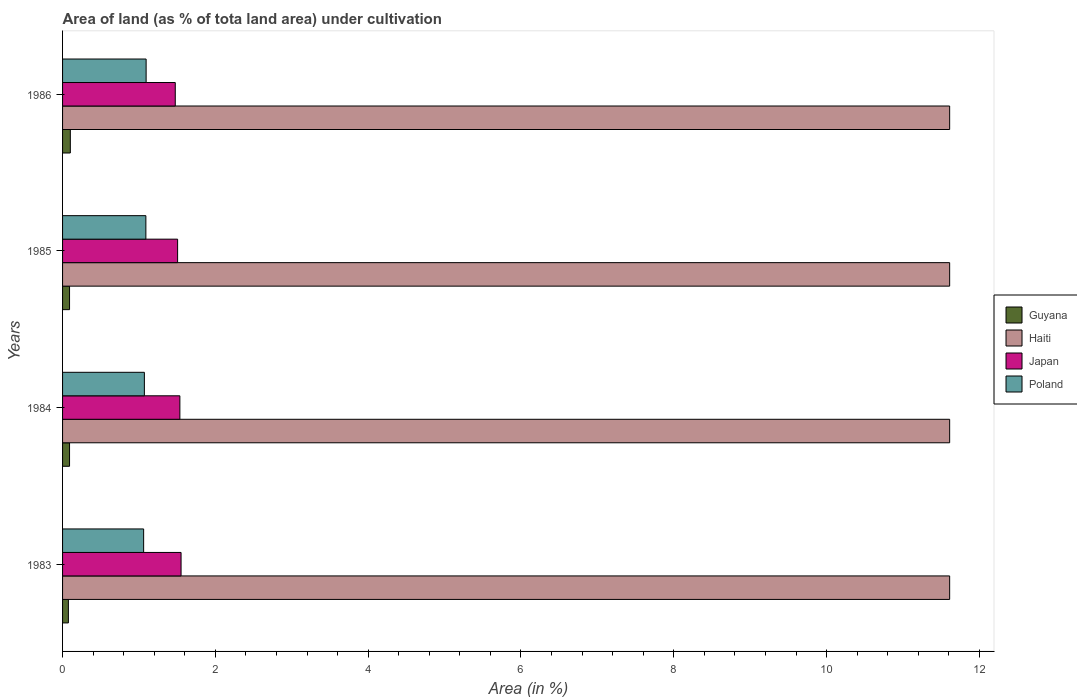How many different coloured bars are there?
Offer a very short reply. 4. How many groups of bars are there?
Give a very brief answer. 4. What is the label of the 2nd group of bars from the top?
Keep it short and to the point. 1985. What is the percentage of land under cultivation in Haiti in 1984?
Make the answer very short. 11.61. Across all years, what is the maximum percentage of land under cultivation in Haiti?
Keep it short and to the point. 11.61. Across all years, what is the minimum percentage of land under cultivation in Poland?
Give a very brief answer. 1.06. In which year was the percentage of land under cultivation in Haiti maximum?
Your answer should be compact. 1983. What is the total percentage of land under cultivation in Poland in the graph?
Provide a short and direct response. 4.32. What is the difference between the percentage of land under cultivation in Poland in 1983 and that in 1985?
Your answer should be compact. -0.03. What is the difference between the percentage of land under cultivation in Japan in 1984 and the percentage of land under cultivation in Guyana in 1986?
Your answer should be very brief. 1.43. What is the average percentage of land under cultivation in Guyana per year?
Your response must be concise. 0.09. In the year 1985, what is the difference between the percentage of land under cultivation in Poland and percentage of land under cultivation in Haiti?
Offer a terse response. -10.52. What is the ratio of the percentage of land under cultivation in Guyana in 1983 to that in 1984?
Provide a short and direct response. 0.83. Is the percentage of land under cultivation in Japan in 1983 less than that in 1985?
Your answer should be very brief. No. What is the difference between the highest and the second highest percentage of land under cultivation in Poland?
Ensure brevity in your answer.  0. What is the difference between the highest and the lowest percentage of land under cultivation in Poland?
Your answer should be compact. 0.03. Is it the case that in every year, the sum of the percentage of land under cultivation in Haiti and percentage of land under cultivation in Japan is greater than the sum of percentage of land under cultivation in Poland and percentage of land under cultivation in Guyana?
Provide a short and direct response. No. What does the 3rd bar from the bottom in 1985 represents?
Provide a succinct answer. Japan. Is it the case that in every year, the sum of the percentage of land under cultivation in Haiti and percentage of land under cultivation in Guyana is greater than the percentage of land under cultivation in Poland?
Offer a terse response. Yes. How many bars are there?
Give a very brief answer. 16. Are all the bars in the graph horizontal?
Give a very brief answer. Yes. Are the values on the major ticks of X-axis written in scientific E-notation?
Keep it short and to the point. No. Does the graph contain any zero values?
Your answer should be very brief. No. Where does the legend appear in the graph?
Keep it short and to the point. Center right. How many legend labels are there?
Provide a succinct answer. 4. What is the title of the graph?
Provide a succinct answer. Area of land (as % of tota land area) under cultivation. What is the label or title of the X-axis?
Your answer should be compact. Area (in %). What is the Area (in %) in Guyana in 1983?
Your answer should be compact. 0.08. What is the Area (in %) of Haiti in 1983?
Your answer should be very brief. 11.61. What is the Area (in %) in Japan in 1983?
Provide a short and direct response. 1.55. What is the Area (in %) in Poland in 1983?
Offer a very short reply. 1.06. What is the Area (in %) of Guyana in 1984?
Make the answer very short. 0.09. What is the Area (in %) of Haiti in 1984?
Offer a terse response. 11.61. What is the Area (in %) in Japan in 1984?
Offer a terse response. 1.54. What is the Area (in %) of Poland in 1984?
Your answer should be very brief. 1.07. What is the Area (in %) of Guyana in 1985?
Offer a terse response. 0.09. What is the Area (in %) in Haiti in 1985?
Provide a succinct answer. 11.61. What is the Area (in %) in Japan in 1985?
Ensure brevity in your answer.  1.51. What is the Area (in %) of Poland in 1985?
Your answer should be very brief. 1.09. What is the Area (in %) of Guyana in 1986?
Offer a very short reply. 0.1. What is the Area (in %) of Haiti in 1986?
Your answer should be very brief. 11.61. What is the Area (in %) of Japan in 1986?
Provide a succinct answer. 1.48. What is the Area (in %) in Poland in 1986?
Your answer should be compact. 1.09. Across all years, what is the maximum Area (in %) in Guyana?
Keep it short and to the point. 0.1. Across all years, what is the maximum Area (in %) of Haiti?
Offer a terse response. 11.61. Across all years, what is the maximum Area (in %) of Japan?
Your answer should be compact. 1.55. Across all years, what is the maximum Area (in %) of Poland?
Your answer should be compact. 1.09. Across all years, what is the minimum Area (in %) in Guyana?
Provide a short and direct response. 0.08. Across all years, what is the minimum Area (in %) in Haiti?
Keep it short and to the point. 11.61. Across all years, what is the minimum Area (in %) in Japan?
Make the answer very short. 1.48. Across all years, what is the minimum Area (in %) in Poland?
Make the answer very short. 1.06. What is the total Area (in %) in Guyana in the graph?
Make the answer very short. 0.36. What is the total Area (in %) of Haiti in the graph?
Your answer should be very brief. 46.44. What is the total Area (in %) of Japan in the graph?
Offer a very short reply. 6.07. What is the total Area (in %) in Poland in the graph?
Provide a short and direct response. 4.32. What is the difference between the Area (in %) of Guyana in 1983 and that in 1984?
Your answer should be very brief. -0.02. What is the difference between the Area (in %) in Japan in 1983 and that in 1984?
Offer a very short reply. 0.02. What is the difference between the Area (in %) of Poland in 1983 and that in 1984?
Make the answer very short. -0.01. What is the difference between the Area (in %) in Guyana in 1983 and that in 1985?
Make the answer very short. -0.02. What is the difference between the Area (in %) in Haiti in 1983 and that in 1985?
Your response must be concise. 0. What is the difference between the Area (in %) in Japan in 1983 and that in 1985?
Keep it short and to the point. 0.05. What is the difference between the Area (in %) of Poland in 1983 and that in 1985?
Offer a terse response. -0.03. What is the difference between the Area (in %) in Guyana in 1983 and that in 1986?
Your response must be concise. -0.03. What is the difference between the Area (in %) of Japan in 1983 and that in 1986?
Offer a terse response. 0.08. What is the difference between the Area (in %) of Poland in 1983 and that in 1986?
Make the answer very short. -0.03. What is the difference between the Area (in %) in Japan in 1984 and that in 1985?
Provide a short and direct response. 0.03. What is the difference between the Area (in %) of Poland in 1984 and that in 1985?
Your answer should be compact. -0.02. What is the difference between the Area (in %) of Guyana in 1984 and that in 1986?
Provide a succinct answer. -0.01. What is the difference between the Area (in %) in Haiti in 1984 and that in 1986?
Offer a terse response. 0. What is the difference between the Area (in %) of Japan in 1984 and that in 1986?
Provide a succinct answer. 0.06. What is the difference between the Area (in %) in Poland in 1984 and that in 1986?
Give a very brief answer. -0.02. What is the difference between the Area (in %) of Guyana in 1985 and that in 1986?
Your answer should be very brief. -0.01. What is the difference between the Area (in %) in Japan in 1985 and that in 1986?
Your answer should be compact. 0.03. What is the difference between the Area (in %) of Poland in 1985 and that in 1986?
Your answer should be compact. -0. What is the difference between the Area (in %) in Guyana in 1983 and the Area (in %) in Haiti in 1984?
Ensure brevity in your answer.  -11.53. What is the difference between the Area (in %) in Guyana in 1983 and the Area (in %) in Japan in 1984?
Provide a short and direct response. -1.46. What is the difference between the Area (in %) in Guyana in 1983 and the Area (in %) in Poland in 1984?
Make the answer very short. -0.99. What is the difference between the Area (in %) in Haiti in 1983 and the Area (in %) in Japan in 1984?
Provide a succinct answer. 10.08. What is the difference between the Area (in %) of Haiti in 1983 and the Area (in %) of Poland in 1984?
Keep it short and to the point. 10.54. What is the difference between the Area (in %) of Japan in 1983 and the Area (in %) of Poland in 1984?
Your response must be concise. 0.48. What is the difference between the Area (in %) of Guyana in 1983 and the Area (in %) of Haiti in 1985?
Offer a very short reply. -11.53. What is the difference between the Area (in %) in Guyana in 1983 and the Area (in %) in Japan in 1985?
Your answer should be very brief. -1.43. What is the difference between the Area (in %) of Guyana in 1983 and the Area (in %) of Poland in 1985?
Make the answer very short. -1.01. What is the difference between the Area (in %) of Haiti in 1983 and the Area (in %) of Japan in 1985?
Offer a very short reply. 10.11. What is the difference between the Area (in %) of Haiti in 1983 and the Area (in %) of Poland in 1985?
Your answer should be compact. 10.52. What is the difference between the Area (in %) in Japan in 1983 and the Area (in %) in Poland in 1985?
Ensure brevity in your answer.  0.46. What is the difference between the Area (in %) in Guyana in 1983 and the Area (in %) in Haiti in 1986?
Make the answer very short. -11.53. What is the difference between the Area (in %) of Guyana in 1983 and the Area (in %) of Japan in 1986?
Give a very brief answer. -1.4. What is the difference between the Area (in %) of Guyana in 1983 and the Area (in %) of Poland in 1986?
Give a very brief answer. -1.02. What is the difference between the Area (in %) in Haiti in 1983 and the Area (in %) in Japan in 1986?
Offer a terse response. 10.14. What is the difference between the Area (in %) in Haiti in 1983 and the Area (in %) in Poland in 1986?
Ensure brevity in your answer.  10.52. What is the difference between the Area (in %) of Japan in 1983 and the Area (in %) of Poland in 1986?
Your answer should be very brief. 0.46. What is the difference between the Area (in %) in Guyana in 1984 and the Area (in %) in Haiti in 1985?
Your response must be concise. -11.52. What is the difference between the Area (in %) of Guyana in 1984 and the Area (in %) of Japan in 1985?
Your response must be concise. -1.41. What is the difference between the Area (in %) in Guyana in 1984 and the Area (in %) in Poland in 1985?
Give a very brief answer. -1. What is the difference between the Area (in %) of Haiti in 1984 and the Area (in %) of Japan in 1985?
Ensure brevity in your answer.  10.11. What is the difference between the Area (in %) in Haiti in 1984 and the Area (in %) in Poland in 1985?
Provide a short and direct response. 10.52. What is the difference between the Area (in %) of Japan in 1984 and the Area (in %) of Poland in 1985?
Your answer should be compact. 0.45. What is the difference between the Area (in %) of Guyana in 1984 and the Area (in %) of Haiti in 1986?
Ensure brevity in your answer.  -11.52. What is the difference between the Area (in %) of Guyana in 1984 and the Area (in %) of Japan in 1986?
Ensure brevity in your answer.  -1.38. What is the difference between the Area (in %) of Guyana in 1984 and the Area (in %) of Poland in 1986?
Your answer should be very brief. -1. What is the difference between the Area (in %) in Haiti in 1984 and the Area (in %) in Japan in 1986?
Your response must be concise. 10.14. What is the difference between the Area (in %) in Haiti in 1984 and the Area (in %) in Poland in 1986?
Keep it short and to the point. 10.52. What is the difference between the Area (in %) in Japan in 1984 and the Area (in %) in Poland in 1986?
Make the answer very short. 0.44. What is the difference between the Area (in %) of Guyana in 1985 and the Area (in %) of Haiti in 1986?
Your answer should be very brief. -11.52. What is the difference between the Area (in %) in Guyana in 1985 and the Area (in %) in Japan in 1986?
Provide a short and direct response. -1.38. What is the difference between the Area (in %) of Guyana in 1985 and the Area (in %) of Poland in 1986?
Give a very brief answer. -1. What is the difference between the Area (in %) of Haiti in 1985 and the Area (in %) of Japan in 1986?
Make the answer very short. 10.14. What is the difference between the Area (in %) in Haiti in 1985 and the Area (in %) in Poland in 1986?
Your response must be concise. 10.52. What is the difference between the Area (in %) in Japan in 1985 and the Area (in %) in Poland in 1986?
Offer a terse response. 0.41. What is the average Area (in %) of Guyana per year?
Keep it short and to the point. 0.09. What is the average Area (in %) in Haiti per year?
Ensure brevity in your answer.  11.61. What is the average Area (in %) of Japan per year?
Make the answer very short. 1.52. What is the average Area (in %) of Poland per year?
Your answer should be very brief. 1.08. In the year 1983, what is the difference between the Area (in %) of Guyana and Area (in %) of Haiti?
Offer a terse response. -11.53. In the year 1983, what is the difference between the Area (in %) in Guyana and Area (in %) in Japan?
Provide a short and direct response. -1.47. In the year 1983, what is the difference between the Area (in %) of Guyana and Area (in %) of Poland?
Ensure brevity in your answer.  -0.98. In the year 1983, what is the difference between the Area (in %) in Haiti and Area (in %) in Japan?
Your response must be concise. 10.06. In the year 1983, what is the difference between the Area (in %) in Haiti and Area (in %) in Poland?
Keep it short and to the point. 10.55. In the year 1983, what is the difference between the Area (in %) in Japan and Area (in %) in Poland?
Your answer should be very brief. 0.49. In the year 1984, what is the difference between the Area (in %) of Guyana and Area (in %) of Haiti?
Provide a short and direct response. -11.52. In the year 1984, what is the difference between the Area (in %) in Guyana and Area (in %) in Japan?
Ensure brevity in your answer.  -1.44. In the year 1984, what is the difference between the Area (in %) of Guyana and Area (in %) of Poland?
Make the answer very short. -0.98. In the year 1984, what is the difference between the Area (in %) in Haiti and Area (in %) in Japan?
Provide a succinct answer. 10.08. In the year 1984, what is the difference between the Area (in %) in Haiti and Area (in %) in Poland?
Keep it short and to the point. 10.54. In the year 1984, what is the difference between the Area (in %) of Japan and Area (in %) of Poland?
Keep it short and to the point. 0.46. In the year 1985, what is the difference between the Area (in %) in Guyana and Area (in %) in Haiti?
Your answer should be compact. -11.52. In the year 1985, what is the difference between the Area (in %) of Guyana and Area (in %) of Japan?
Offer a terse response. -1.41. In the year 1985, what is the difference between the Area (in %) in Guyana and Area (in %) in Poland?
Make the answer very short. -1. In the year 1985, what is the difference between the Area (in %) in Haiti and Area (in %) in Japan?
Your response must be concise. 10.11. In the year 1985, what is the difference between the Area (in %) in Haiti and Area (in %) in Poland?
Your response must be concise. 10.52. In the year 1985, what is the difference between the Area (in %) of Japan and Area (in %) of Poland?
Provide a succinct answer. 0.42. In the year 1986, what is the difference between the Area (in %) in Guyana and Area (in %) in Haiti?
Your answer should be very brief. -11.51. In the year 1986, what is the difference between the Area (in %) of Guyana and Area (in %) of Japan?
Ensure brevity in your answer.  -1.37. In the year 1986, what is the difference between the Area (in %) of Guyana and Area (in %) of Poland?
Give a very brief answer. -0.99. In the year 1986, what is the difference between the Area (in %) in Haiti and Area (in %) in Japan?
Provide a succinct answer. 10.14. In the year 1986, what is the difference between the Area (in %) of Haiti and Area (in %) of Poland?
Your answer should be very brief. 10.52. In the year 1986, what is the difference between the Area (in %) in Japan and Area (in %) in Poland?
Your response must be concise. 0.38. What is the ratio of the Area (in %) of Haiti in 1983 to that in 1984?
Keep it short and to the point. 1. What is the ratio of the Area (in %) in Poland in 1983 to that in 1984?
Give a very brief answer. 0.99. What is the ratio of the Area (in %) of Guyana in 1983 to that in 1985?
Keep it short and to the point. 0.83. What is the ratio of the Area (in %) in Japan in 1983 to that in 1985?
Keep it short and to the point. 1.03. What is the ratio of the Area (in %) in Poland in 1983 to that in 1985?
Keep it short and to the point. 0.97. What is the ratio of the Area (in %) in Guyana in 1983 to that in 1986?
Your answer should be very brief. 0.75. What is the ratio of the Area (in %) of Haiti in 1983 to that in 1986?
Ensure brevity in your answer.  1. What is the ratio of the Area (in %) of Japan in 1983 to that in 1986?
Provide a succinct answer. 1.05. What is the ratio of the Area (in %) of Poland in 1983 to that in 1986?
Make the answer very short. 0.97. What is the ratio of the Area (in %) in Japan in 1984 to that in 1985?
Give a very brief answer. 1.02. What is the ratio of the Area (in %) of Guyana in 1984 to that in 1986?
Your answer should be compact. 0.9. What is the ratio of the Area (in %) of Haiti in 1984 to that in 1986?
Offer a very short reply. 1. What is the ratio of the Area (in %) of Japan in 1984 to that in 1986?
Ensure brevity in your answer.  1.04. What is the ratio of the Area (in %) of Poland in 1984 to that in 1986?
Give a very brief answer. 0.98. What is the ratio of the Area (in %) of Guyana in 1985 to that in 1986?
Make the answer very short. 0.9. What is the ratio of the Area (in %) in Haiti in 1985 to that in 1986?
Your answer should be very brief. 1. What is the ratio of the Area (in %) in Japan in 1985 to that in 1986?
Make the answer very short. 1.02. What is the ratio of the Area (in %) in Poland in 1985 to that in 1986?
Provide a succinct answer. 1. What is the difference between the highest and the second highest Area (in %) of Guyana?
Give a very brief answer. 0.01. What is the difference between the highest and the second highest Area (in %) in Japan?
Your response must be concise. 0.02. What is the difference between the highest and the second highest Area (in %) in Poland?
Make the answer very short. 0. What is the difference between the highest and the lowest Area (in %) of Guyana?
Provide a short and direct response. 0.03. What is the difference between the highest and the lowest Area (in %) in Japan?
Offer a very short reply. 0.08. What is the difference between the highest and the lowest Area (in %) in Poland?
Offer a terse response. 0.03. 